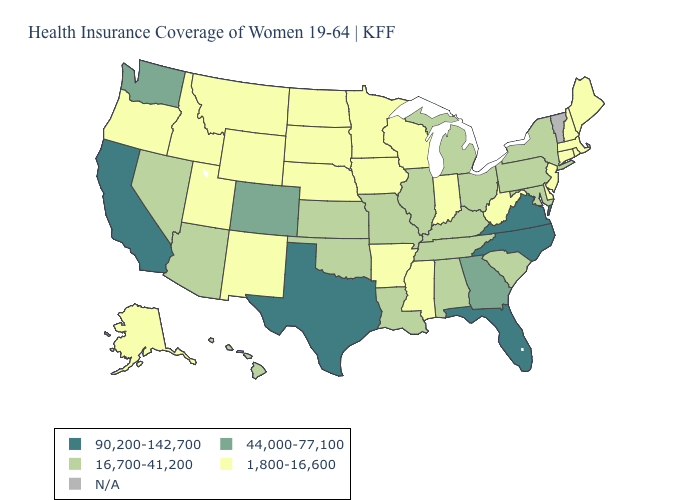What is the value of Arkansas?
Give a very brief answer. 1,800-16,600. What is the value of Ohio?
Keep it brief. 16,700-41,200. Name the states that have a value in the range 1,800-16,600?
Concise answer only. Alaska, Arkansas, Connecticut, Delaware, Idaho, Indiana, Iowa, Maine, Massachusetts, Minnesota, Mississippi, Montana, Nebraska, New Hampshire, New Jersey, New Mexico, North Dakota, Oregon, Rhode Island, South Dakota, Utah, West Virginia, Wisconsin, Wyoming. What is the highest value in states that border Louisiana?
Quick response, please. 90,200-142,700. Does Washington have the lowest value in the USA?
Concise answer only. No. Does Indiana have the highest value in the MidWest?
Answer briefly. No. Does Florida have the highest value in the USA?
Write a very short answer. Yes. Name the states that have a value in the range N/A?
Write a very short answer. Vermont. What is the highest value in the West ?
Short answer required. 90,200-142,700. What is the value of Oregon?
Answer briefly. 1,800-16,600. Does Rhode Island have the lowest value in the Northeast?
Concise answer only. Yes. Is the legend a continuous bar?
Be succinct. No. Name the states that have a value in the range 44,000-77,100?
Give a very brief answer. Colorado, Georgia, Washington. Which states have the highest value in the USA?
Short answer required. California, Florida, North Carolina, Texas, Virginia. Among the states that border New York , does New Jersey have the lowest value?
Short answer required. Yes. 